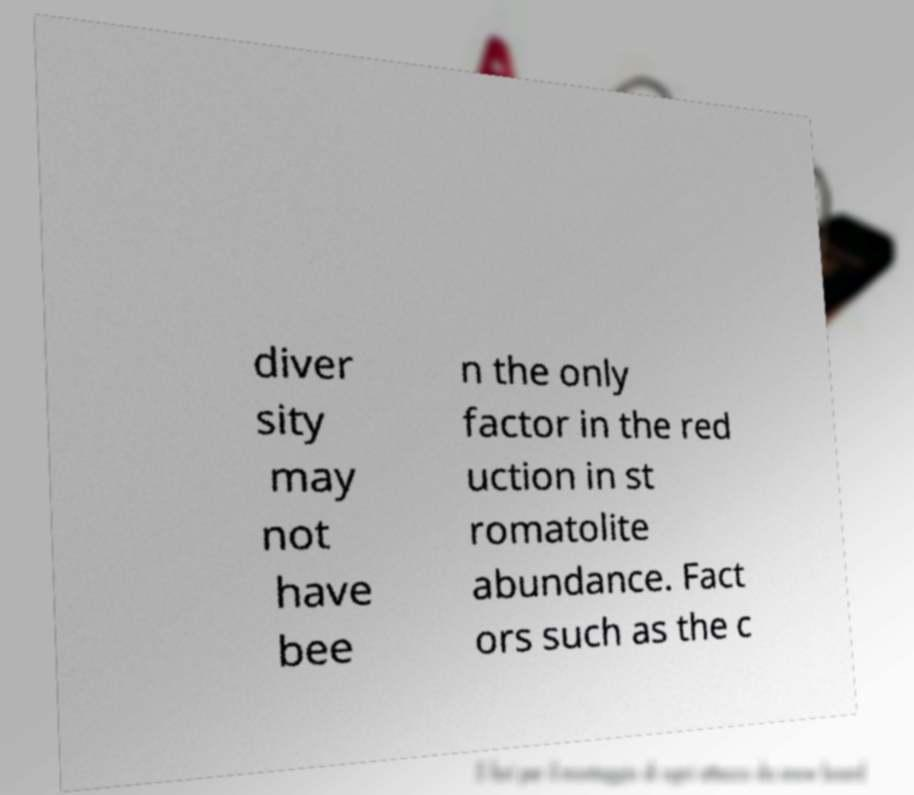Could you assist in decoding the text presented in this image and type it out clearly? diver sity may not have bee n the only factor in the red uction in st romatolite abundance. Fact ors such as the c 